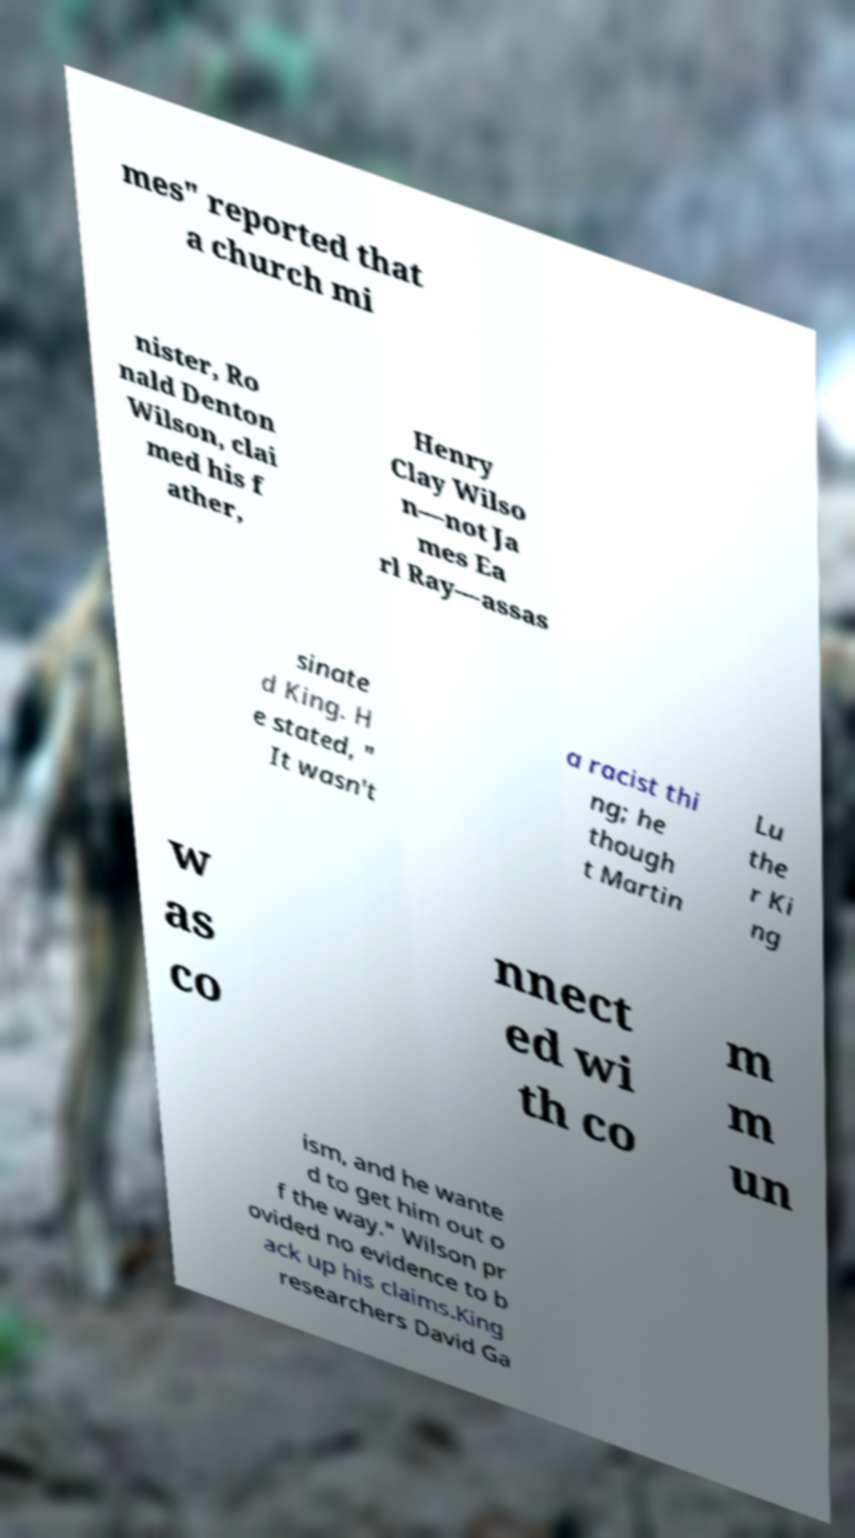I need the written content from this picture converted into text. Can you do that? mes" reported that a church mi nister, Ro nald Denton Wilson, clai med his f ather, Henry Clay Wilso n—not Ja mes Ea rl Ray—assas sinate d King. H e stated, " It wasn't a racist thi ng; he though t Martin Lu the r Ki ng w as co nnect ed wi th co m m un ism, and he wante d to get him out o f the way." Wilson pr ovided no evidence to b ack up his claims.King researchers David Ga 